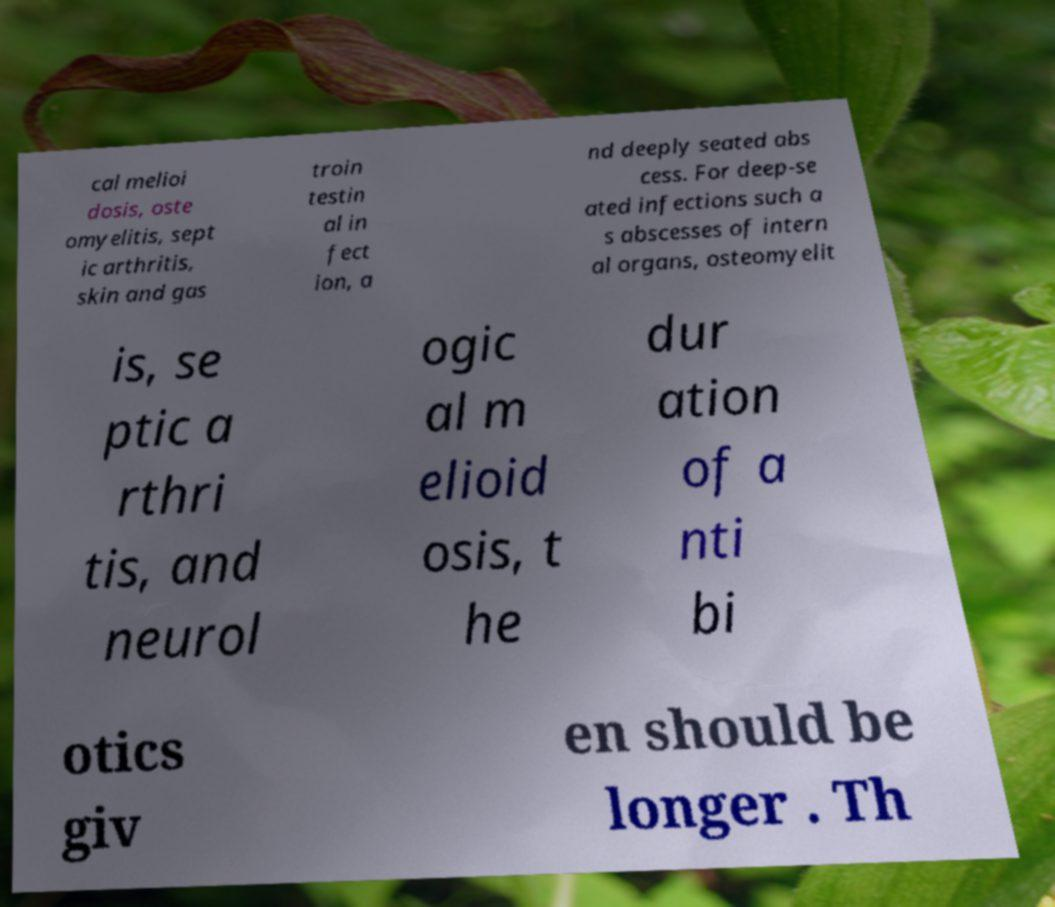I need the written content from this picture converted into text. Can you do that? cal melioi dosis, oste omyelitis, sept ic arthritis, skin and gas troin testin al in fect ion, a nd deeply seated abs cess. For deep-se ated infections such a s abscesses of intern al organs, osteomyelit is, se ptic a rthri tis, and neurol ogic al m elioid osis, t he dur ation of a nti bi otics giv en should be longer . Th 